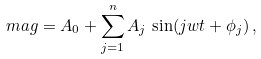<formula> <loc_0><loc_0><loc_500><loc_500>m a g = A _ { 0 } + \sum _ { j = 1 } ^ { n } A _ { j } \, \sin ( j w t + \phi _ { j } ) \, ,</formula> 